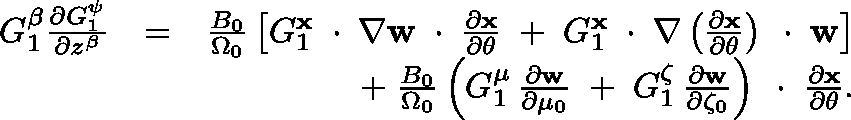<formula> <loc_0><loc_0><loc_500><loc_500>\begin{array} { r l r } { G _ { 1 } ^ { \beta } \frac { \partial G _ { 1 } ^ { \psi } } { \partial z ^ { \beta } } } & { = } & { \frac { B _ { 0 } } { \Omega _ { 0 } } \left [ G _ { 1 } ^ { x } \, \boldmath \cdot \, \nabla { w } \, \boldmath \cdot \, \frac { \partial x } { \partial \theta } \, + \, G _ { 1 } ^ { x } \, \boldmath \cdot \, \nabla \left ( \frac { \partial x } { \partial \theta } \right ) \, \boldmath \cdot \, { w } \right ] } \\ & { + \, \frac { B _ { 0 } } { \Omega _ { 0 } } \left ( G _ { 1 } ^ { \mu } \, \frac { \partial w } { \partial \mu _ { 0 } } \, + \, G _ { 1 } ^ { \zeta } \, \frac { \partial w } { \partial \zeta _ { 0 } } \right ) \, \boldmath \cdot \, \frac { \partial x } { \partial \theta } . } \end{array}</formula> 